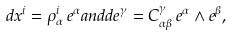Convert formula to latex. <formula><loc_0><loc_0><loc_500><loc_500>d x ^ { i } = \rho ^ { i } _ { \alpha } \, e ^ { \alpha } a n d d e ^ { \gamma } = C _ { \alpha \beta } ^ { \gamma } \, e ^ { \alpha } \land e ^ { \beta } ,</formula> 